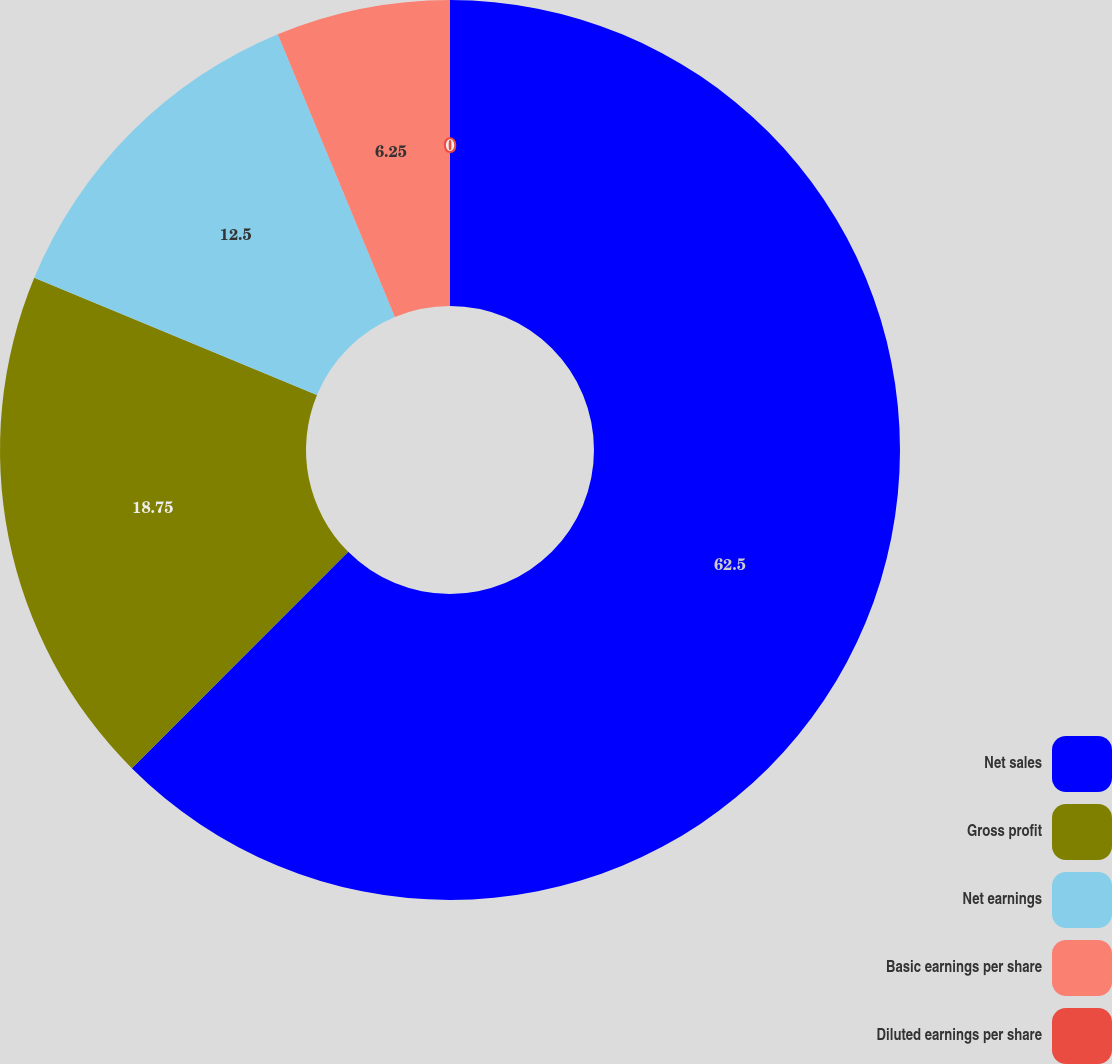<chart> <loc_0><loc_0><loc_500><loc_500><pie_chart><fcel>Net sales<fcel>Gross profit<fcel>Net earnings<fcel>Basic earnings per share<fcel>Diluted earnings per share<nl><fcel>62.5%<fcel>18.75%<fcel>12.5%<fcel>6.25%<fcel>0.0%<nl></chart> 